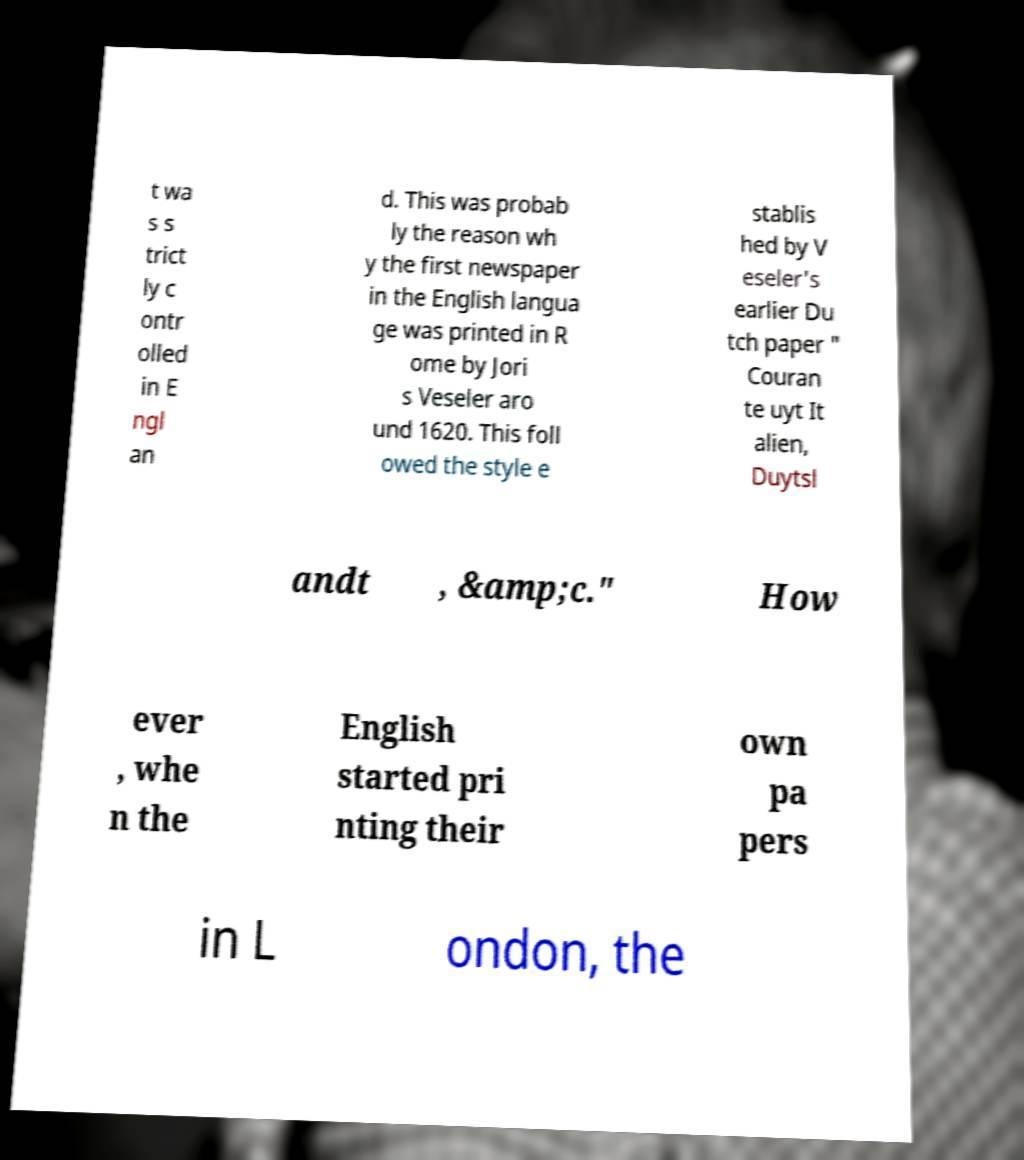Could you extract and type out the text from this image? t wa s s trict ly c ontr olled in E ngl an d. This was probab ly the reason wh y the first newspaper in the English langua ge was printed in R ome by Jori s Veseler aro und 1620. This foll owed the style e stablis hed by V eseler's earlier Du tch paper " Couran te uyt It alien, Duytsl andt , &amp;c." How ever , whe n the English started pri nting their own pa pers in L ondon, the 